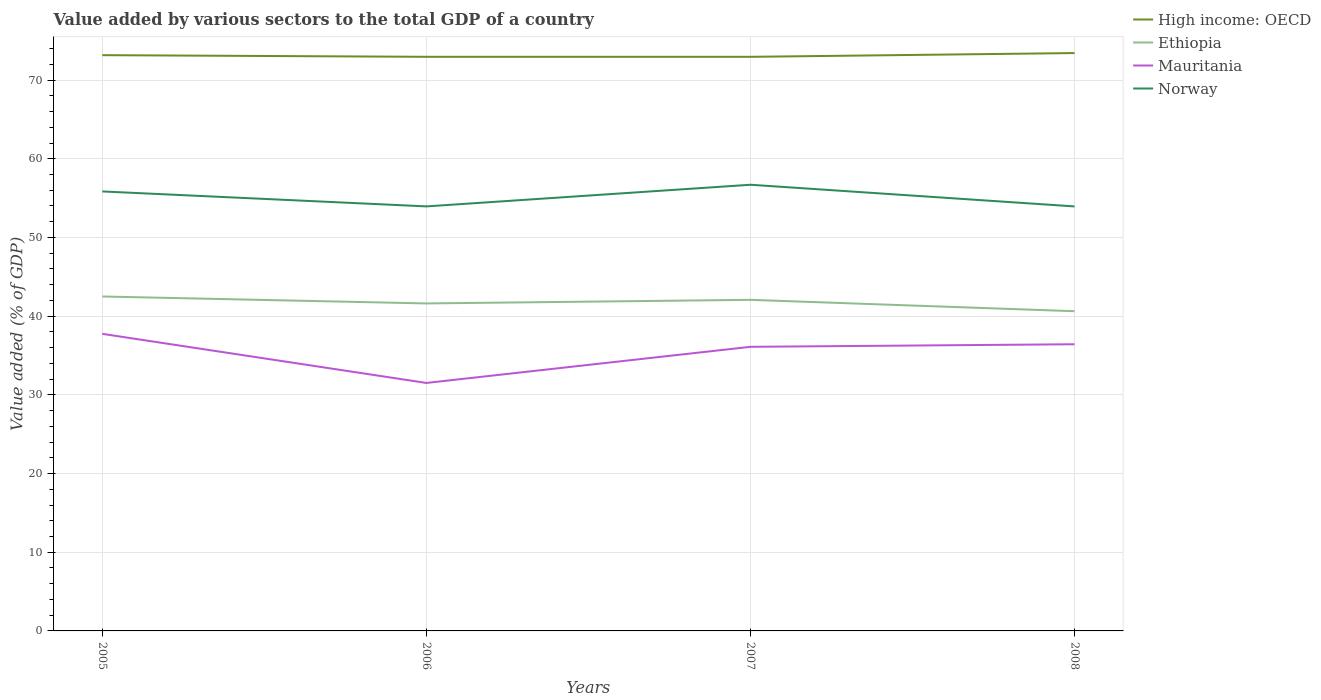How many different coloured lines are there?
Offer a terse response. 4. Across all years, what is the maximum value added by various sectors to the total GDP in Ethiopia?
Provide a short and direct response. 40.63. In which year was the value added by various sectors to the total GDP in Mauritania maximum?
Provide a short and direct response. 2006. What is the total value added by various sectors to the total GDP in Ethiopia in the graph?
Give a very brief answer. -0.46. What is the difference between the highest and the second highest value added by various sectors to the total GDP in Ethiopia?
Provide a short and direct response. 1.87. What is the difference between the highest and the lowest value added by various sectors to the total GDP in Ethiopia?
Provide a succinct answer. 2. Is the value added by various sectors to the total GDP in Mauritania strictly greater than the value added by various sectors to the total GDP in Norway over the years?
Ensure brevity in your answer.  Yes. How many lines are there?
Your response must be concise. 4. How many years are there in the graph?
Provide a short and direct response. 4. What is the difference between two consecutive major ticks on the Y-axis?
Keep it short and to the point. 10. Does the graph contain any zero values?
Ensure brevity in your answer.  No. Does the graph contain grids?
Your response must be concise. Yes. Where does the legend appear in the graph?
Your answer should be compact. Top right. What is the title of the graph?
Keep it short and to the point. Value added by various sectors to the total GDP of a country. What is the label or title of the X-axis?
Your response must be concise. Years. What is the label or title of the Y-axis?
Provide a succinct answer. Value added (% of GDP). What is the Value added (% of GDP) in High income: OECD in 2005?
Provide a short and direct response. 73.16. What is the Value added (% of GDP) of Ethiopia in 2005?
Provide a succinct answer. 42.5. What is the Value added (% of GDP) in Mauritania in 2005?
Give a very brief answer. 37.75. What is the Value added (% of GDP) of Norway in 2005?
Give a very brief answer. 55.85. What is the Value added (% of GDP) of High income: OECD in 2006?
Your answer should be very brief. 72.96. What is the Value added (% of GDP) in Ethiopia in 2006?
Your response must be concise. 41.62. What is the Value added (% of GDP) of Mauritania in 2006?
Provide a short and direct response. 31.51. What is the Value added (% of GDP) of Norway in 2006?
Give a very brief answer. 53.95. What is the Value added (% of GDP) of High income: OECD in 2007?
Provide a short and direct response. 72.95. What is the Value added (% of GDP) of Ethiopia in 2007?
Offer a terse response. 42.07. What is the Value added (% of GDP) of Mauritania in 2007?
Your answer should be very brief. 36.1. What is the Value added (% of GDP) of Norway in 2007?
Ensure brevity in your answer.  56.7. What is the Value added (% of GDP) of High income: OECD in 2008?
Your answer should be very brief. 73.43. What is the Value added (% of GDP) in Ethiopia in 2008?
Provide a succinct answer. 40.63. What is the Value added (% of GDP) of Mauritania in 2008?
Make the answer very short. 36.43. What is the Value added (% of GDP) in Norway in 2008?
Your response must be concise. 53.94. Across all years, what is the maximum Value added (% of GDP) of High income: OECD?
Provide a succinct answer. 73.43. Across all years, what is the maximum Value added (% of GDP) of Ethiopia?
Provide a succinct answer. 42.5. Across all years, what is the maximum Value added (% of GDP) in Mauritania?
Your response must be concise. 37.75. Across all years, what is the maximum Value added (% of GDP) of Norway?
Your response must be concise. 56.7. Across all years, what is the minimum Value added (% of GDP) of High income: OECD?
Keep it short and to the point. 72.95. Across all years, what is the minimum Value added (% of GDP) in Ethiopia?
Your response must be concise. 40.63. Across all years, what is the minimum Value added (% of GDP) in Mauritania?
Provide a short and direct response. 31.51. Across all years, what is the minimum Value added (% of GDP) of Norway?
Make the answer very short. 53.94. What is the total Value added (% of GDP) of High income: OECD in the graph?
Ensure brevity in your answer.  292.5. What is the total Value added (% of GDP) in Ethiopia in the graph?
Make the answer very short. 166.81. What is the total Value added (% of GDP) in Mauritania in the graph?
Offer a terse response. 141.79. What is the total Value added (% of GDP) in Norway in the graph?
Provide a short and direct response. 220.43. What is the difference between the Value added (% of GDP) of High income: OECD in 2005 and that in 2006?
Provide a succinct answer. 0.21. What is the difference between the Value added (% of GDP) in Ethiopia in 2005 and that in 2006?
Offer a terse response. 0.88. What is the difference between the Value added (% of GDP) in Mauritania in 2005 and that in 2006?
Provide a succinct answer. 6.24. What is the difference between the Value added (% of GDP) of Norway in 2005 and that in 2006?
Your answer should be very brief. 1.9. What is the difference between the Value added (% of GDP) of High income: OECD in 2005 and that in 2007?
Give a very brief answer. 0.21. What is the difference between the Value added (% of GDP) of Ethiopia in 2005 and that in 2007?
Offer a terse response. 0.43. What is the difference between the Value added (% of GDP) in Mauritania in 2005 and that in 2007?
Offer a very short reply. 1.65. What is the difference between the Value added (% of GDP) of Norway in 2005 and that in 2007?
Make the answer very short. -0.85. What is the difference between the Value added (% of GDP) in High income: OECD in 2005 and that in 2008?
Give a very brief answer. -0.27. What is the difference between the Value added (% of GDP) of Ethiopia in 2005 and that in 2008?
Provide a short and direct response. 1.87. What is the difference between the Value added (% of GDP) of Mauritania in 2005 and that in 2008?
Offer a terse response. 1.32. What is the difference between the Value added (% of GDP) of Norway in 2005 and that in 2008?
Provide a short and direct response. 1.9. What is the difference between the Value added (% of GDP) of High income: OECD in 2006 and that in 2007?
Give a very brief answer. 0. What is the difference between the Value added (% of GDP) of Ethiopia in 2006 and that in 2007?
Offer a very short reply. -0.46. What is the difference between the Value added (% of GDP) in Mauritania in 2006 and that in 2007?
Make the answer very short. -4.59. What is the difference between the Value added (% of GDP) in Norway in 2006 and that in 2007?
Offer a terse response. -2.75. What is the difference between the Value added (% of GDP) of High income: OECD in 2006 and that in 2008?
Give a very brief answer. -0.48. What is the difference between the Value added (% of GDP) of Mauritania in 2006 and that in 2008?
Your answer should be very brief. -4.92. What is the difference between the Value added (% of GDP) in Norway in 2006 and that in 2008?
Provide a succinct answer. 0. What is the difference between the Value added (% of GDP) of High income: OECD in 2007 and that in 2008?
Keep it short and to the point. -0.48. What is the difference between the Value added (% of GDP) of Ethiopia in 2007 and that in 2008?
Your answer should be very brief. 1.45. What is the difference between the Value added (% of GDP) in Mauritania in 2007 and that in 2008?
Keep it short and to the point. -0.33. What is the difference between the Value added (% of GDP) of Norway in 2007 and that in 2008?
Make the answer very short. 2.75. What is the difference between the Value added (% of GDP) in High income: OECD in 2005 and the Value added (% of GDP) in Ethiopia in 2006?
Provide a short and direct response. 31.55. What is the difference between the Value added (% of GDP) in High income: OECD in 2005 and the Value added (% of GDP) in Mauritania in 2006?
Ensure brevity in your answer.  41.65. What is the difference between the Value added (% of GDP) in High income: OECD in 2005 and the Value added (% of GDP) in Norway in 2006?
Your answer should be compact. 19.22. What is the difference between the Value added (% of GDP) of Ethiopia in 2005 and the Value added (% of GDP) of Mauritania in 2006?
Give a very brief answer. 10.99. What is the difference between the Value added (% of GDP) of Ethiopia in 2005 and the Value added (% of GDP) of Norway in 2006?
Your response must be concise. -11.45. What is the difference between the Value added (% of GDP) in Mauritania in 2005 and the Value added (% of GDP) in Norway in 2006?
Your answer should be compact. -16.2. What is the difference between the Value added (% of GDP) of High income: OECD in 2005 and the Value added (% of GDP) of Ethiopia in 2007?
Keep it short and to the point. 31.09. What is the difference between the Value added (% of GDP) of High income: OECD in 2005 and the Value added (% of GDP) of Mauritania in 2007?
Give a very brief answer. 37.06. What is the difference between the Value added (% of GDP) in High income: OECD in 2005 and the Value added (% of GDP) in Norway in 2007?
Your answer should be very brief. 16.47. What is the difference between the Value added (% of GDP) in Ethiopia in 2005 and the Value added (% of GDP) in Mauritania in 2007?
Provide a short and direct response. 6.4. What is the difference between the Value added (% of GDP) of Ethiopia in 2005 and the Value added (% of GDP) of Norway in 2007?
Make the answer very short. -14.2. What is the difference between the Value added (% of GDP) of Mauritania in 2005 and the Value added (% of GDP) of Norway in 2007?
Give a very brief answer. -18.95. What is the difference between the Value added (% of GDP) in High income: OECD in 2005 and the Value added (% of GDP) in Ethiopia in 2008?
Offer a very short reply. 32.54. What is the difference between the Value added (% of GDP) in High income: OECD in 2005 and the Value added (% of GDP) in Mauritania in 2008?
Ensure brevity in your answer.  36.74. What is the difference between the Value added (% of GDP) of High income: OECD in 2005 and the Value added (% of GDP) of Norway in 2008?
Give a very brief answer. 19.22. What is the difference between the Value added (% of GDP) of Ethiopia in 2005 and the Value added (% of GDP) of Mauritania in 2008?
Provide a succinct answer. 6.07. What is the difference between the Value added (% of GDP) in Ethiopia in 2005 and the Value added (% of GDP) in Norway in 2008?
Your response must be concise. -11.44. What is the difference between the Value added (% of GDP) in Mauritania in 2005 and the Value added (% of GDP) in Norway in 2008?
Give a very brief answer. -16.19. What is the difference between the Value added (% of GDP) of High income: OECD in 2006 and the Value added (% of GDP) of Ethiopia in 2007?
Offer a very short reply. 30.88. What is the difference between the Value added (% of GDP) in High income: OECD in 2006 and the Value added (% of GDP) in Mauritania in 2007?
Keep it short and to the point. 36.85. What is the difference between the Value added (% of GDP) of High income: OECD in 2006 and the Value added (% of GDP) of Norway in 2007?
Your answer should be compact. 16.26. What is the difference between the Value added (% of GDP) in Ethiopia in 2006 and the Value added (% of GDP) in Mauritania in 2007?
Make the answer very short. 5.51. What is the difference between the Value added (% of GDP) of Ethiopia in 2006 and the Value added (% of GDP) of Norway in 2007?
Ensure brevity in your answer.  -15.08. What is the difference between the Value added (% of GDP) in Mauritania in 2006 and the Value added (% of GDP) in Norway in 2007?
Your answer should be compact. -25.19. What is the difference between the Value added (% of GDP) in High income: OECD in 2006 and the Value added (% of GDP) in Ethiopia in 2008?
Offer a terse response. 32.33. What is the difference between the Value added (% of GDP) in High income: OECD in 2006 and the Value added (% of GDP) in Mauritania in 2008?
Your answer should be very brief. 36.53. What is the difference between the Value added (% of GDP) of High income: OECD in 2006 and the Value added (% of GDP) of Norway in 2008?
Your answer should be very brief. 19.01. What is the difference between the Value added (% of GDP) in Ethiopia in 2006 and the Value added (% of GDP) in Mauritania in 2008?
Keep it short and to the point. 5.19. What is the difference between the Value added (% of GDP) in Ethiopia in 2006 and the Value added (% of GDP) in Norway in 2008?
Your response must be concise. -12.33. What is the difference between the Value added (% of GDP) in Mauritania in 2006 and the Value added (% of GDP) in Norway in 2008?
Your answer should be compact. -22.43. What is the difference between the Value added (% of GDP) in High income: OECD in 2007 and the Value added (% of GDP) in Ethiopia in 2008?
Your answer should be very brief. 32.33. What is the difference between the Value added (% of GDP) in High income: OECD in 2007 and the Value added (% of GDP) in Mauritania in 2008?
Offer a terse response. 36.52. What is the difference between the Value added (% of GDP) in High income: OECD in 2007 and the Value added (% of GDP) in Norway in 2008?
Offer a terse response. 19.01. What is the difference between the Value added (% of GDP) of Ethiopia in 2007 and the Value added (% of GDP) of Mauritania in 2008?
Your response must be concise. 5.64. What is the difference between the Value added (% of GDP) in Ethiopia in 2007 and the Value added (% of GDP) in Norway in 2008?
Keep it short and to the point. -11.87. What is the difference between the Value added (% of GDP) in Mauritania in 2007 and the Value added (% of GDP) in Norway in 2008?
Your response must be concise. -17.84. What is the average Value added (% of GDP) of High income: OECD per year?
Offer a very short reply. 73.13. What is the average Value added (% of GDP) in Ethiopia per year?
Your answer should be very brief. 41.7. What is the average Value added (% of GDP) of Mauritania per year?
Offer a terse response. 35.45. What is the average Value added (% of GDP) of Norway per year?
Your answer should be very brief. 55.11. In the year 2005, what is the difference between the Value added (% of GDP) in High income: OECD and Value added (% of GDP) in Ethiopia?
Keep it short and to the point. 30.67. In the year 2005, what is the difference between the Value added (% of GDP) in High income: OECD and Value added (% of GDP) in Mauritania?
Offer a very short reply. 35.41. In the year 2005, what is the difference between the Value added (% of GDP) in High income: OECD and Value added (% of GDP) in Norway?
Your answer should be compact. 17.32. In the year 2005, what is the difference between the Value added (% of GDP) of Ethiopia and Value added (% of GDP) of Mauritania?
Your answer should be compact. 4.75. In the year 2005, what is the difference between the Value added (% of GDP) of Ethiopia and Value added (% of GDP) of Norway?
Ensure brevity in your answer.  -13.35. In the year 2005, what is the difference between the Value added (% of GDP) of Mauritania and Value added (% of GDP) of Norway?
Offer a terse response. -18.1. In the year 2006, what is the difference between the Value added (% of GDP) in High income: OECD and Value added (% of GDP) in Ethiopia?
Ensure brevity in your answer.  31.34. In the year 2006, what is the difference between the Value added (% of GDP) of High income: OECD and Value added (% of GDP) of Mauritania?
Make the answer very short. 41.44. In the year 2006, what is the difference between the Value added (% of GDP) of High income: OECD and Value added (% of GDP) of Norway?
Provide a succinct answer. 19.01. In the year 2006, what is the difference between the Value added (% of GDP) of Ethiopia and Value added (% of GDP) of Mauritania?
Make the answer very short. 10.1. In the year 2006, what is the difference between the Value added (% of GDP) of Ethiopia and Value added (% of GDP) of Norway?
Provide a succinct answer. -12.33. In the year 2006, what is the difference between the Value added (% of GDP) in Mauritania and Value added (% of GDP) in Norway?
Give a very brief answer. -22.44. In the year 2007, what is the difference between the Value added (% of GDP) in High income: OECD and Value added (% of GDP) in Ethiopia?
Your answer should be very brief. 30.88. In the year 2007, what is the difference between the Value added (% of GDP) in High income: OECD and Value added (% of GDP) in Mauritania?
Offer a very short reply. 36.85. In the year 2007, what is the difference between the Value added (% of GDP) in High income: OECD and Value added (% of GDP) in Norway?
Make the answer very short. 16.25. In the year 2007, what is the difference between the Value added (% of GDP) in Ethiopia and Value added (% of GDP) in Mauritania?
Offer a terse response. 5.97. In the year 2007, what is the difference between the Value added (% of GDP) of Ethiopia and Value added (% of GDP) of Norway?
Provide a short and direct response. -14.62. In the year 2007, what is the difference between the Value added (% of GDP) in Mauritania and Value added (% of GDP) in Norway?
Keep it short and to the point. -20.59. In the year 2008, what is the difference between the Value added (% of GDP) of High income: OECD and Value added (% of GDP) of Ethiopia?
Your response must be concise. 32.8. In the year 2008, what is the difference between the Value added (% of GDP) in High income: OECD and Value added (% of GDP) in Mauritania?
Offer a very short reply. 37. In the year 2008, what is the difference between the Value added (% of GDP) of High income: OECD and Value added (% of GDP) of Norway?
Offer a terse response. 19.49. In the year 2008, what is the difference between the Value added (% of GDP) of Ethiopia and Value added (% of GDP) of Mauritania?
Provide a short and direct response. 4.2. In the year 2008, what is the difference between the Value added (% of GDP) of Ethiopia and Value added (% of GDP) of Norway?
Ensure brevity in your answer.  -13.32. In the year 2008, what is the difference between the Value added (% of GDP) of Mauritania and Value added (% of GDP) of Norway?
Make the answer very short. -17.51. What is the ratio of the Value added (% of GDP) in High income: OECD in 2005 to that in 2006?
Your answer should be compact. 1. What is the ratio of the Value added (% of GDP) in Ethiopia in 2005 to that in 2006?
Your answer should be very brief. 1.02. What is the ratio of the Value added (% of GDP) of Mauritania in 2005 to that in 2006?
Ensure brevity in your answer.  1.2. What is the ratio of the Value added (% of GDP) in Norway in 2005 to that in 2006?
Provide a short and direct response. 1.04. What is the ratio of the Value added (% of GDP) in High income: OECD in 2005 to that in 2007?
Your response must be concise. 1. What is the ratio of the Value added (% of GDP) in Mauritania in 2005 to that in 2007?
Make the answer very short. 1.05. What is the ratio of the Value added (% of GDP) of Norway in 2005 to that in 2007?
Give a very brief answer. 0.98. What is the ratio of the Value added (% of GDP) of High income: OECD in 2005 to that in 2008?
Keep it short and to the point. 1. What is the ratio of the Value added (% of GDP) in Ethiopia in 2005 to that in 2008?
Keep it short and to the point. 1.05. What is the ratio of the Value added (% of GDP) in Mauritania in 2005 to that in 2008?
Offer a terse response. 1.04. What is the ratio of the Value added (% of GDP) of Norway in 2005 to that in 2008?
Your answer should be compact. 1.04. What is the ratio of the Value added (% of GDP) in Mauritania in 2006 to that in 2007?
Your response must be concise. 0.87. What is the ratio of the Value added (% of GDP) in Norway in 2006 to that in 2007?
Your response must be concise. 0.95. What is the ratio of the Value added (% of GDP) in High income: OECD in 2006 to that in 2008?
Offer a terse response. 0.99. What is the ratio of the Value added (% of GDP) in Ethiopia in 2006 to that in 2008?
Offer a very short reply. 1.02. What is the ratio of the Value added (% of GDP) in Mauritania in 2006 to that in 2008?
Your answer should be very brief. 0.86. What is the ratio of the Value added (% of GDP) of Ethiopia in 2007 to that in 2008?
Your answer should be compact. 1.04. What is the ratio of the Value added (% of GDP) of Mauritania in 2007 to that in 2008?
Offer a terse response. 0.99. What is the ratio of the Value added (% of GDP) of Norway in 2007 to that in 2008?
Keep it short and to the point. 1.05. What is the difference between the highest and the second highest Value added (% of GDP) in High income: OECD?
Make the answer very short. 0.27. What is the difference between the highest and the second highest Value added (% of GDP) of Ethiopia?
Your response must be concise. 0.43. What is the difference between the highest and the second highest Value added (% of GDP) of Mauritania?
Provide a succinct answer. 1.32. What is the difference between the highest and the lowest Value added (% of GDP) in High income: OECD?
Your answer should be compact. 0.48. What is the difference between the highest and the lowest Value added (% of GDP) of Ethiopia?
Your answer should be very brief. 1.87. What is the difference between the highest and the lowest Value added (% of GDP) of Mauritania?
Your answer should be very brief. 6.24. What is the difference between the highest and the lowest Value added (% of GDP) of Norway?
Provide a short and direct response. 2.75. 